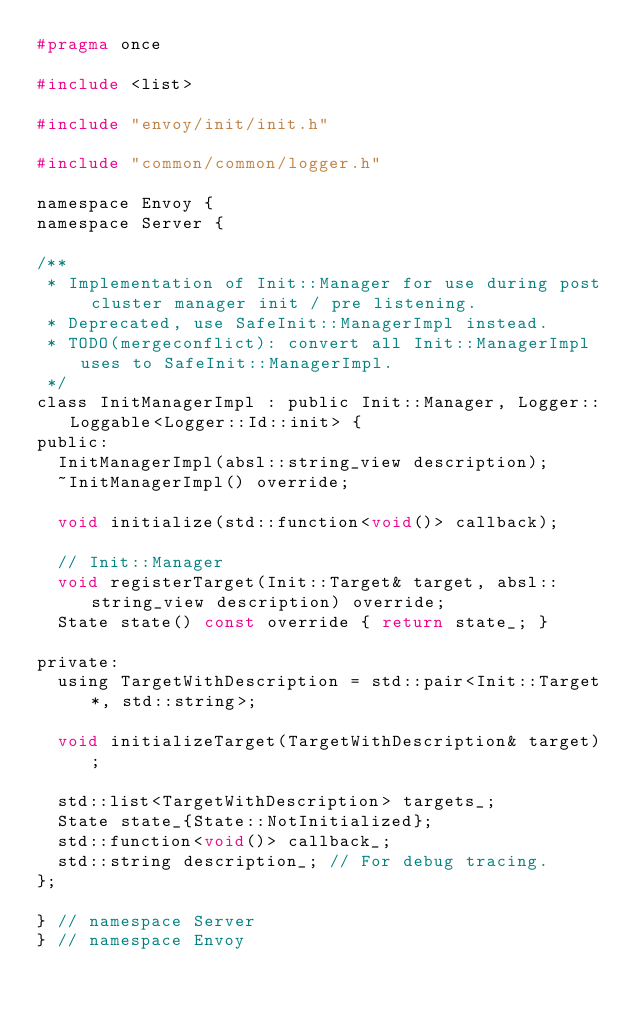Convert code to text. <code><loc_0><loc_0><loc_500><loc_500><_C_>#pragma once

#include <list>

#include "envoy/init/init.h"

#include "common/common/logger.h"

namespace Envoy {
namespace Server {

/**
 * Implementation of Init::Manager for use during post cluster manager init / pre listening.
 * Deprecated, use SafeInit::ManagerImpl instead.
 * TODO(mergeconflict): convert all Init::ManagerImpl uses to SafeInit::ManagerImpl.
 */
class InitManagerImpl : public Init::Manager, Logger::Loggable<Logger::Id::init> {
public:
  InitManagerImpl(absl::string_view description);
  ~InitManagerImpl() override;

  void initialize(std::function<void()> callback);

  // Init::Manager
  void registerTarget(Init::Target& target, absl::string_view description) override;
  State state() const override { return state_; }

private:
  using TargetWithDescription = std::pair<Init::Target*, std::string>;

  void initializeTarget(TargetWithDescription& target);

  std::list<TargetWithDescription> targets_;
  State state_{State::NotInitialized};
  std::function<void()> callback_;
  std::string description_; // For debug tracing.
};

} // namespace Server
} // namespace Envoy
</code> 